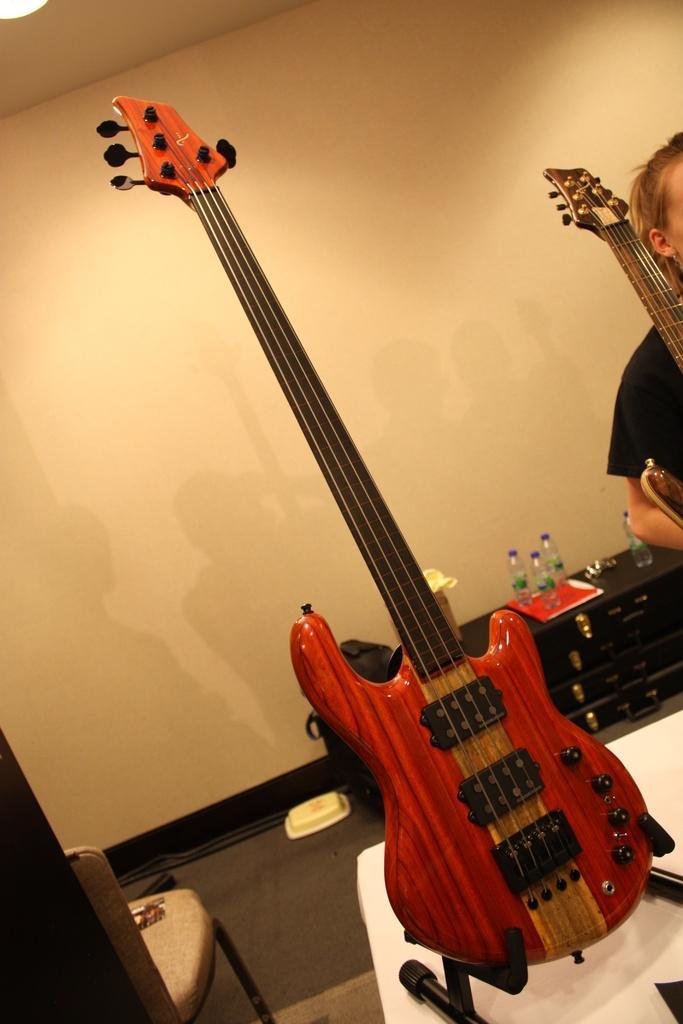Describe this image in one or two sentences. In this picture I can see in the middle there is a guitar, on the right side there is a person. In the background there are bottles and a wall. On the left side there is a chair. 